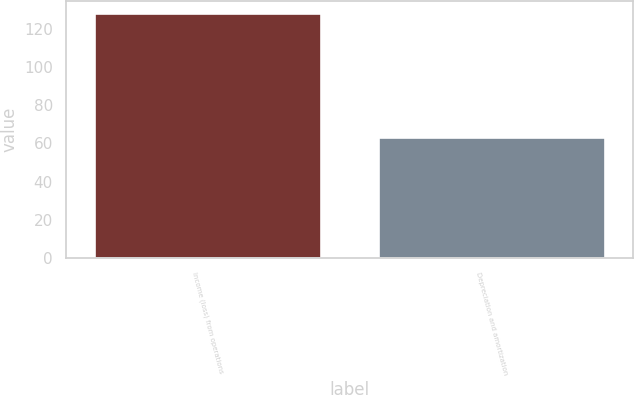<chart> <loc_0><loc_0><loc_500><loc_500><bar_chart><fcel>Income (loss) from operations<fcel>Depreciation and amortization<nl><fcel>128.4<fcel>63.3<nl></chart> 